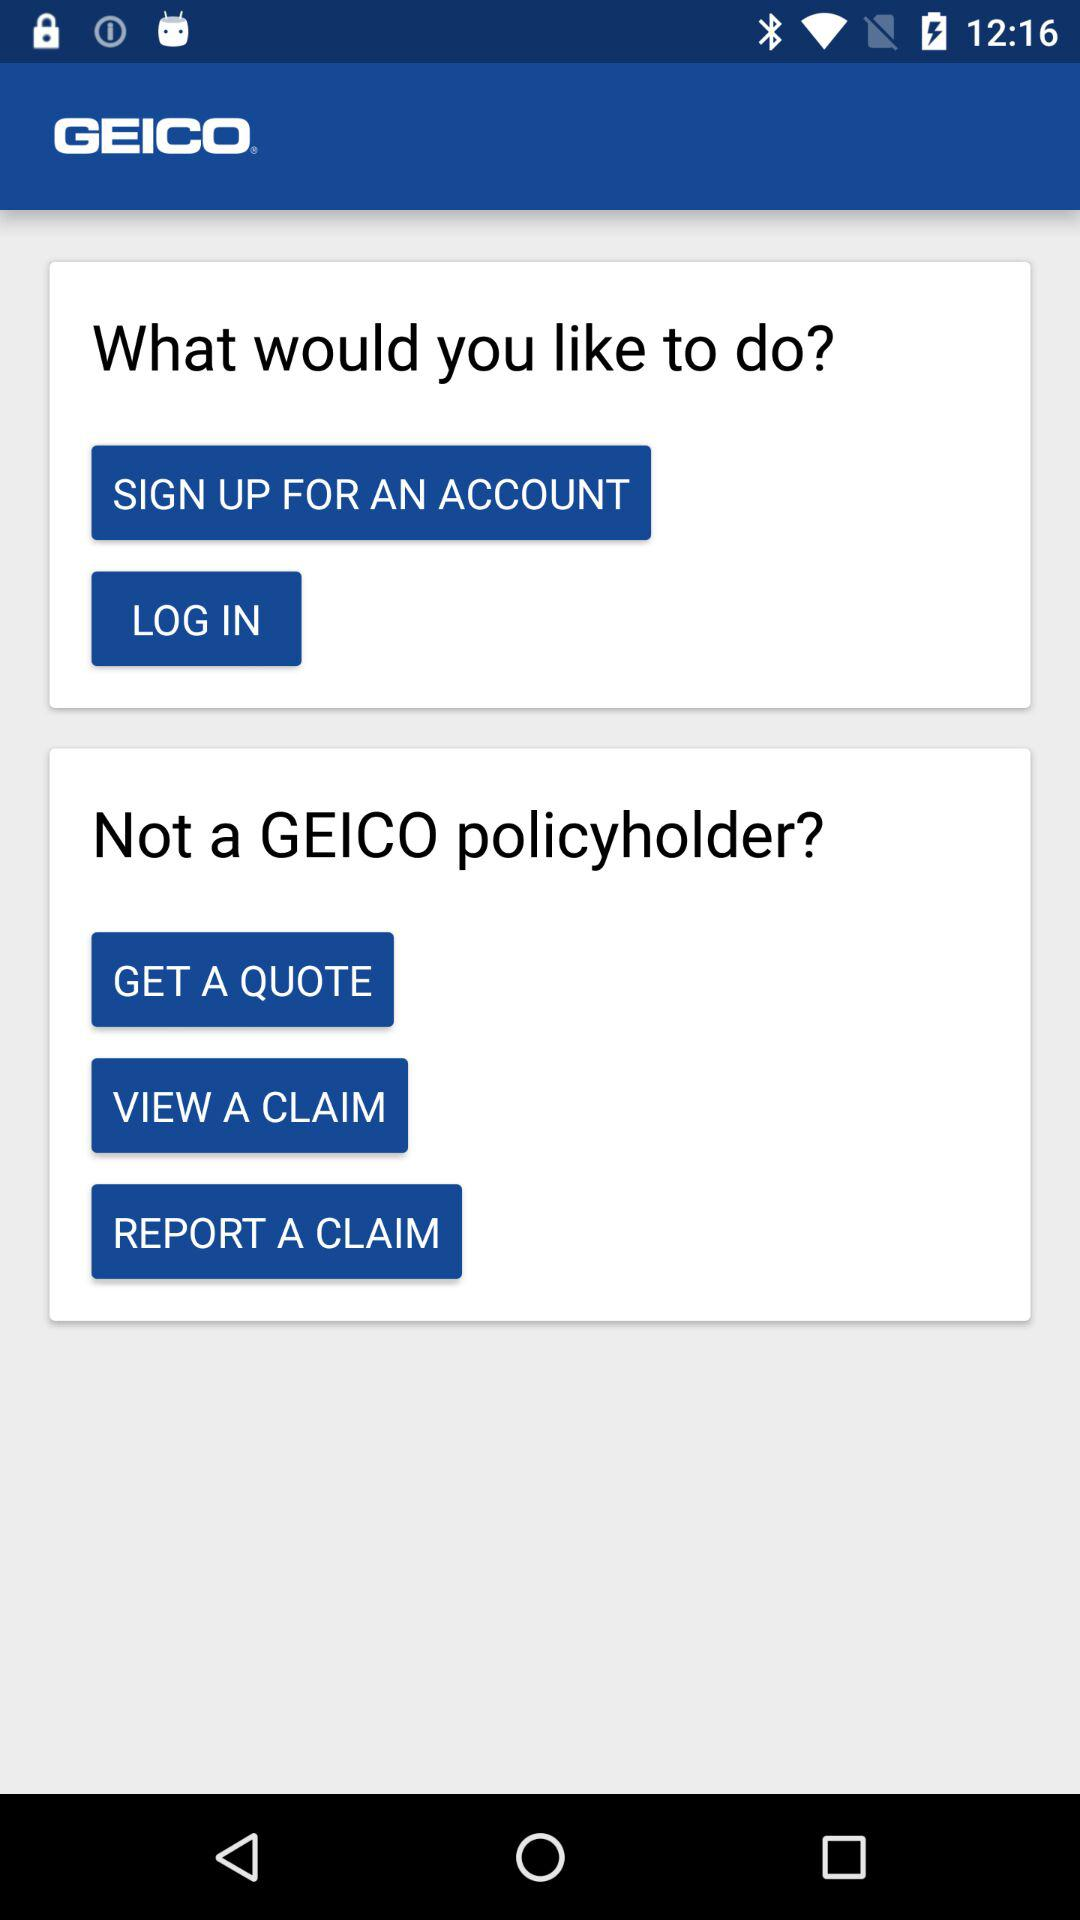What is the name of the application? The name of the application is "GEICO". 